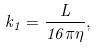<formula> <loc_0><loc_0><loc_500><loc_500>k _ { 1 } = \frac { L } { 1 6 \pi \eta } ,</formula> 